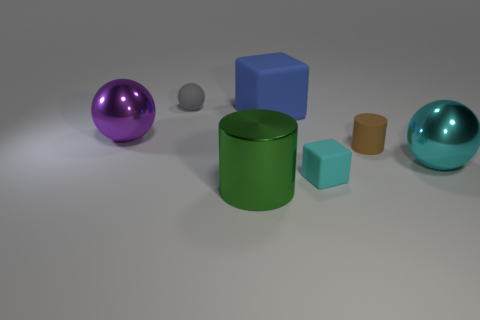Add 1 small cyan balls. How many objects exist? 8 Subtract all cylinders. How many objects are left? 5 Add 1 purple balls. How many purple balls exist? 2 Subtract 0 red cylinders. How many objects are left? 7 Subtract all cyan things. Subtract all cyan blocks. How many objects are left? 4 Add 2 small gray things. How many small gray things are left? 3 